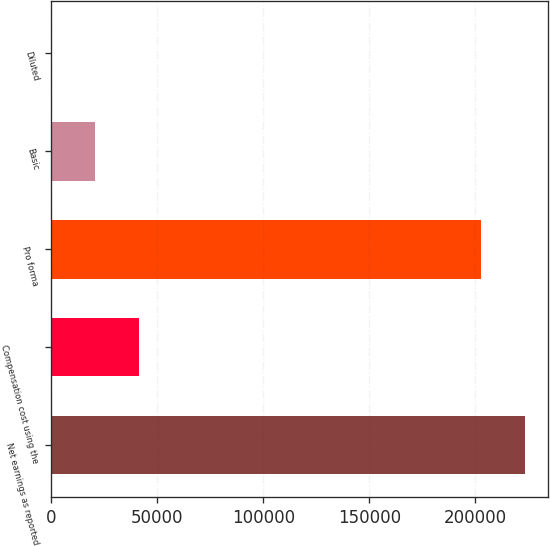<chart> <loc_0><loc_0><loc_500><loc_500><bar_chart><fcel>Net earnings as reported<fcel>Compensation cost using the<fcel>Pro forma<fcel>Basic<fcel>Diluted<nl><fcel>223277<fcel>41463.2<fcel>202546<fcel>20732.2<fcel>1.28<nl></chart> 